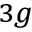<formula> <loc_0><loc_0><loc_500><loc_500>_ { 3 g }</formula> 